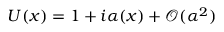<formula> <loc_0><loc_0><loc_500><loc_500>U ( x ) = 1 + i \alpha ( x ) + { \mathcal { O } } ( \alpha ^ { 2 } )</formula> 